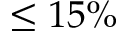Convert formula to latex. <formula><loc_0><loc_0><loc_500><loc_500>\leq 1 5 \%</formula> 